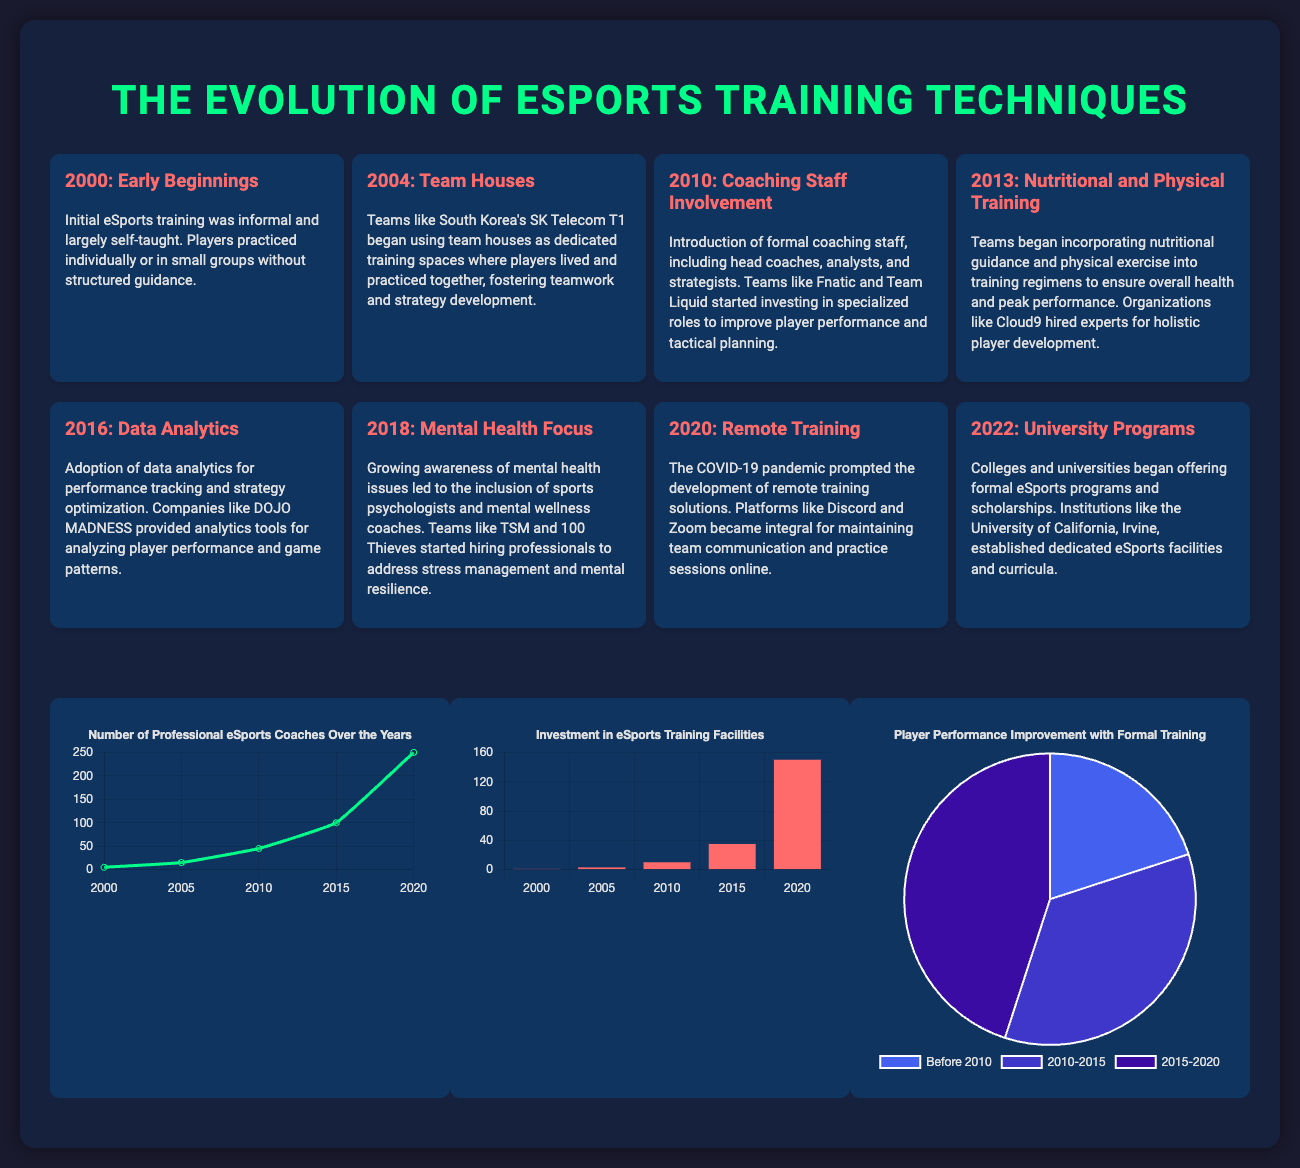What year marked the introduction of formal coaching staff in eSports? The introduction of formal coaching staff occurred in 2010, as noted in the timeline section of the document.
Answer: 2010 Which team was noted for using team houses in 2004? The timeline specifies that South Korea's SK Telecom T1 began using team houses in 2004.
Answer: SK Telecom T1 What type of training was introduced in 2013? The document indicates that nutritional guidance and physical training were incorporated into training regimens in 2013.
Answer: Nutritional and Physical Training In which year did the investment in eSports training facilities reach 150 million? According to the investment chart, the investment in eSports training facilities reached 150 million in 2020.
Answer: 2020 How many professional eSports coaches were there in 2005? The coaches chart shows that there were 15 professional eSports coaches in 2005.
Answer: 15 Which chart illustrates player performance improvement with formal training? The document contains a pie chart that illustrates player performance improvement with formal training.
Answer: Performance Chart What is the percentage of player performance improvement between 2010 and 2015? The pie chart indicates that the percentage of player performance improvement between 2010 and 2015 was 35%.
Answer: 35% What was a key focus for teams in 2018? As per the timeline, a key focus for teams in 2018 was mental health.
Answer: Mental Health Focus What significant change occurred in training due to the COVID-19 pandemic? The document states that remote training solutions became integral due to the COVID-19 pandemic.
Answer: Remote Training Solutions 